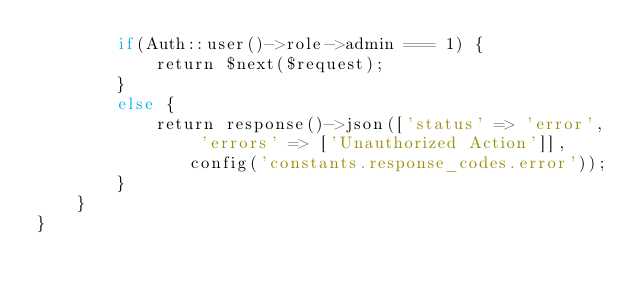<code> <loc_0><loc_0><loc_500><loc_500><_PHP_>        if(Auth::user()->role->admin === 1) {
            return $next($request);
        }
        else {
            return response()->json(['status' => 'error', 'errors' => ['Unauthorized Action']], config('constants.response_codes.error'));
        }
    }
}</code> 